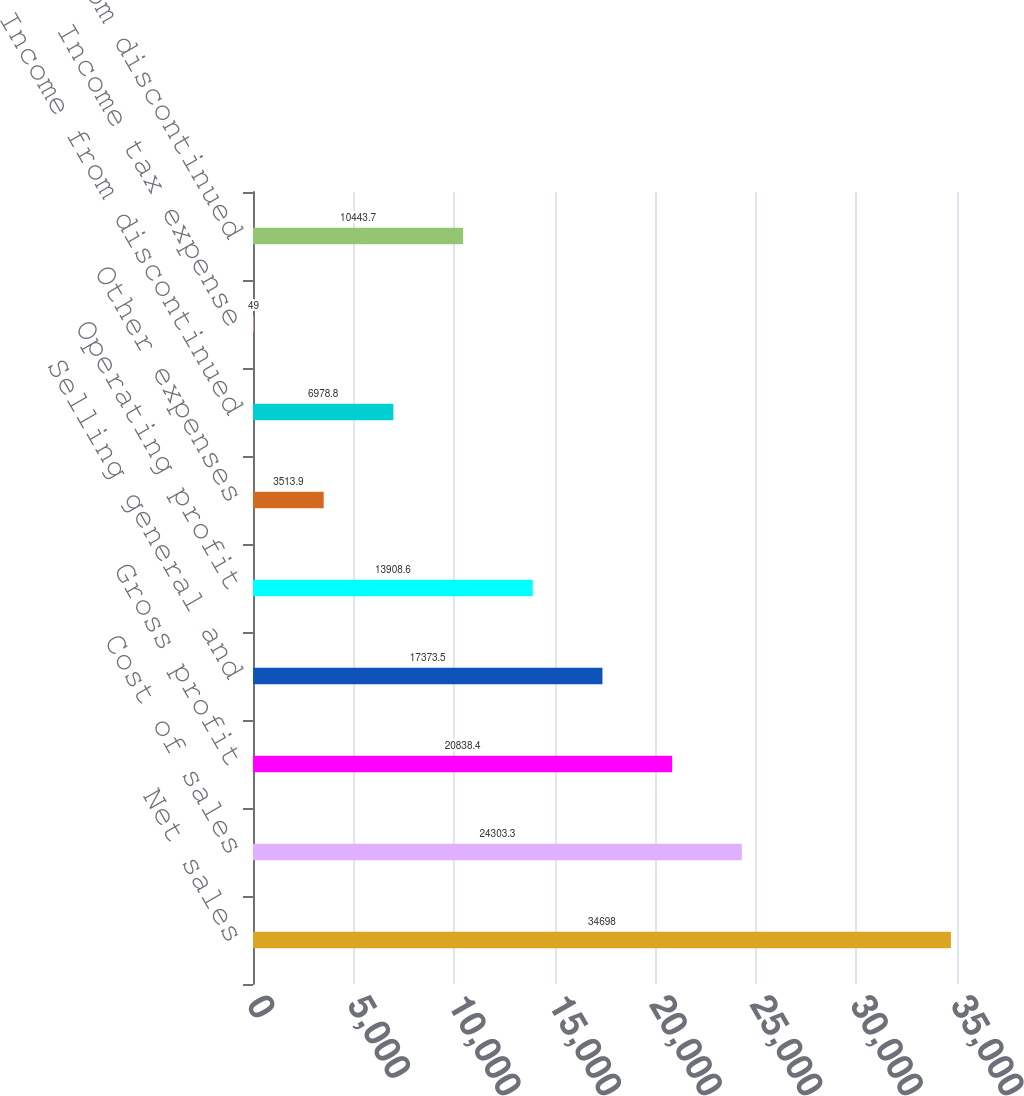Convert chart to OTSL. <chart><loc_0><loc_0><loc_500><loc_500><bar_chart><fcel>Net sales<fcel>Cost of sales<fcel>Gross profit<fcel>Selling general and<fcel>Operating profit<fcel>Other expenses<fcel>Income from discontinued<fcel>Income tax expense<fcel>Net income from discontinued<nl><fcel>34698<fcel>24303.3<fcel>20838.4<fcel>17373.5<fcel>13908.6<fcel>3513.9<fcel>6978.8<fcel>49<fcel>10443.7<nl></chart> 